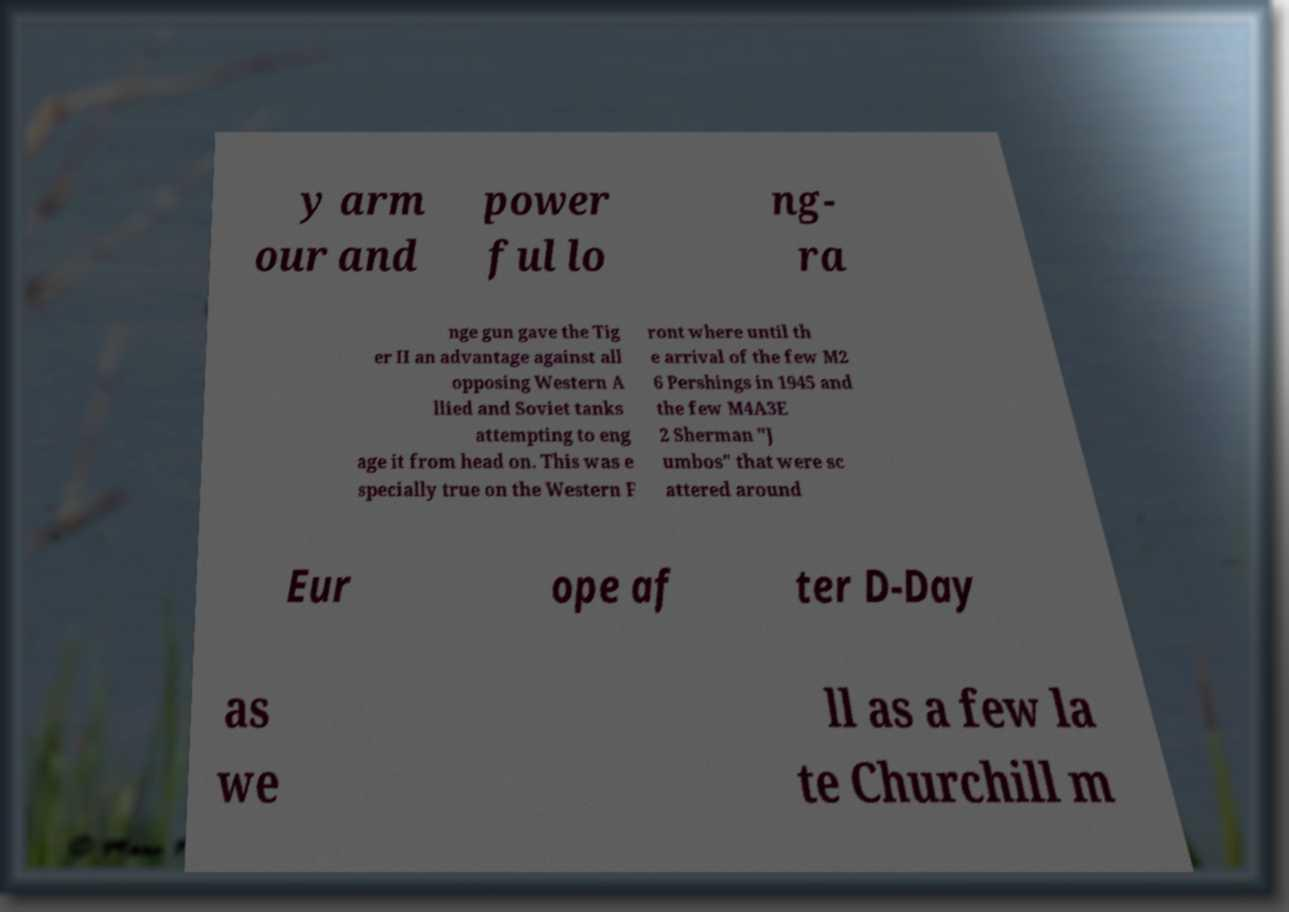I need the written content from this picture converted into text. Can you do that? y arm our and power ful lo ng- ra nge gun gave the Tig er II an advantage against all opposing Western A llied and Soviet tanks attempting to eng age it from head on. This was e specially true on the Western F ront where until th e arrival of the few M2 6 Pershings in 1945 and the few M4A3E 2 Sherman "J umbos" that were sc attered around Eur ope af ter D-Day as we ll as a few la te Churchill m 